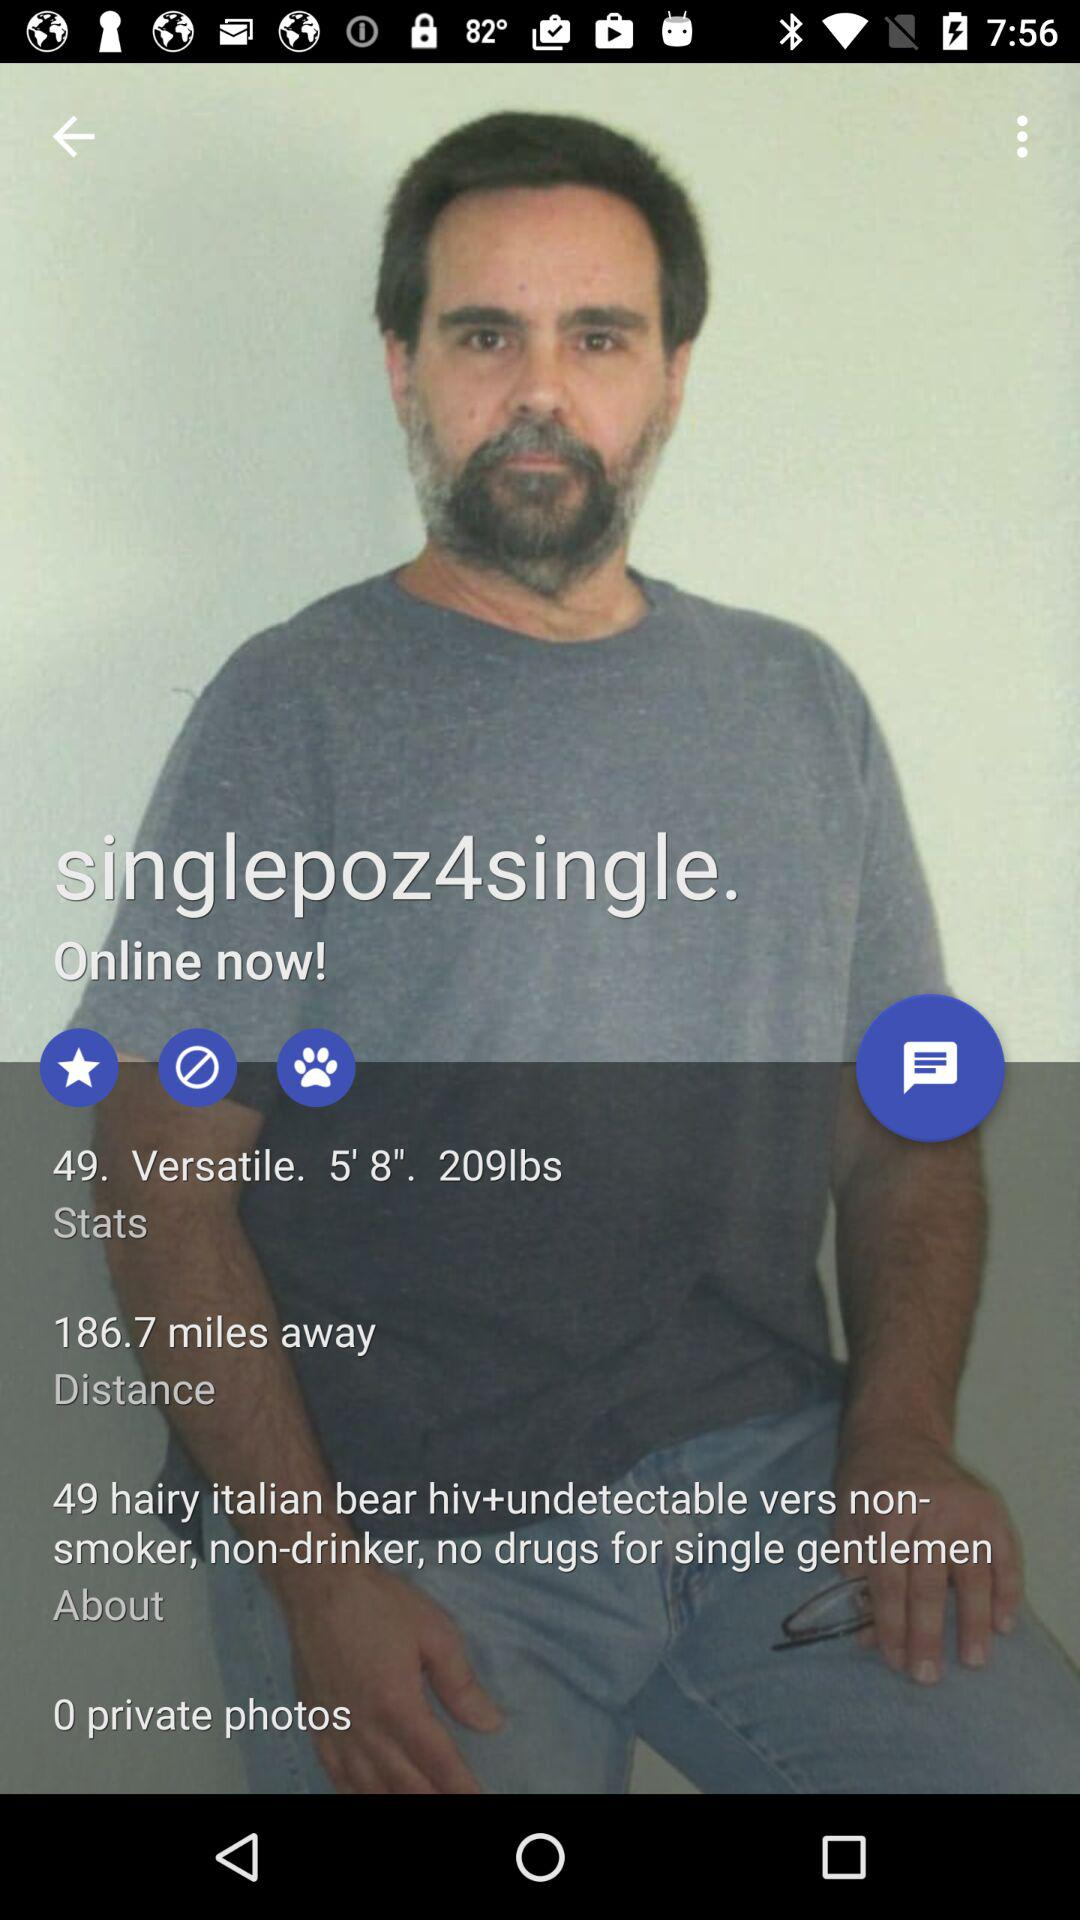What is the age of the man? The man is 49 years old. 